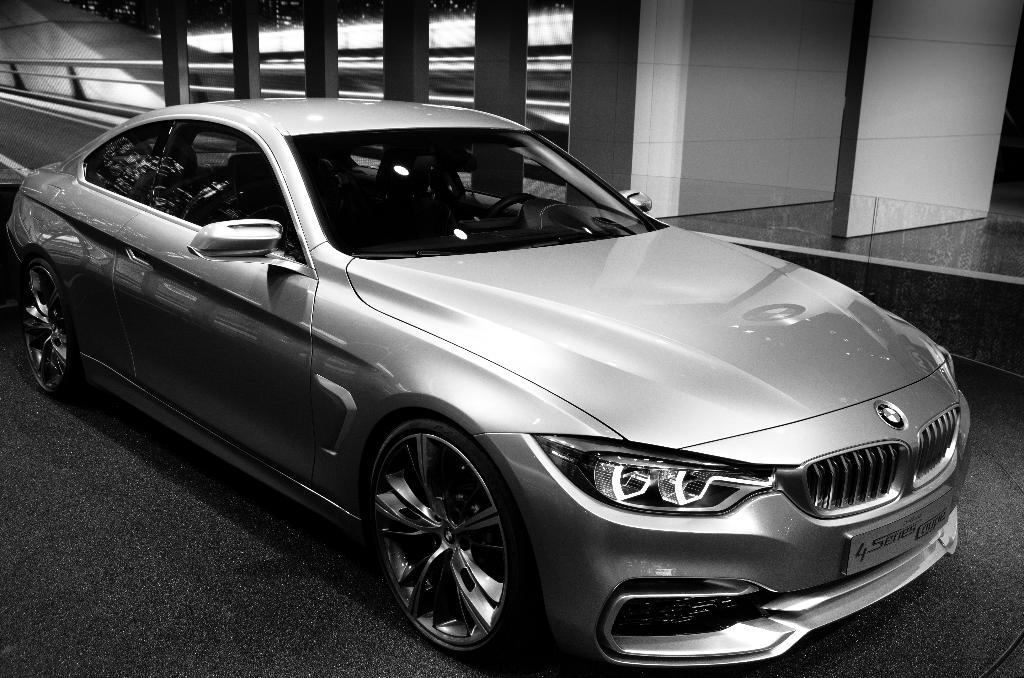What is the color scheme of the image? The image is black and white. What can be seen in the image? There is a car in the image. How many dust particles can be seen on the car in the image? There is no mention of dust particles in the image, so it is not possible to determine their number. 